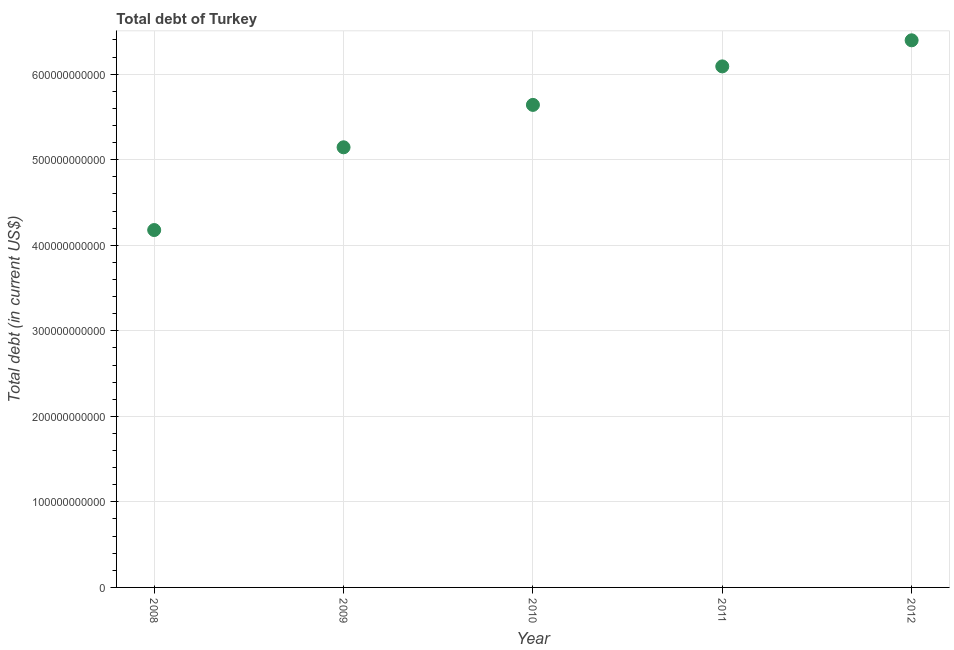What is the total debt in 2010?
Ensure brevity in your answer.  5.64e+11. Across all years, what is the maximum total debt?
Your answer should be very brief. 6.40e+11. Across all years, what is the minimum total debt?
Your answer should be compact. 4.18e+11. In which year was the total debt minimum?
Keep it short and to the point. 2008. What is the sum of the total debt?
Your answer should be very brief. 2.75e+12. What is the difference between the total debt in 2010 and 2012?
Keep it short and to the point. -7.55e+1. What is the average total debt per year?
Provide a succinct answer. 5.49e+11. What is the median total debt?
Your answer should be compact. 5.64e+11. In how many years, is the total debt greater than 380000000000 US$?
Provide a succinct answer. 5. What is the ratio of the total debt in 2008 to that in 2010?
Ensure brevity in your answer.  0.74. Is the total debt in 2008 less than that in 2009?
Provide a short and direct response. Yes. What is the difference between the highest and the second highest total debt?
Offer a terse response. 3.05e+1. What is the difference between the highest and the lowest total debt?
Ensure brevity in your answer.  2.22e+11. In how many years, is the total debt greater than the average total debt taken over all years?
Your answer should be very brief. 3. Does the total debt monotonically increase over the years?
Keep it short and to the point. Yes. How many years are there in the graph?
Your response must be concise. 5. What is the difference between two consecutive major ticks on the Y-axis?
Offer a terse response. 1.00e+11. Are the values on the major ticks of Y-axis written in scientific E-notation?
Your answer should be compact. No. What is the title of the graph?
Give a very brief answer. Total debt of Turkey. What is the label or title of the X-axis?
Keep it short and to the point. Year. What is the label or title of the Y-axis?
Your answer should be compact. Total debt (in current US$). What is the Total debt (in current US$) in 2008?
Provide a short and direct response. 4.18e+11. What is the Total debt (in current US$) in 2009?
Give a very brief answer. 5.15e+11. What is the Total debt (in current US$) in 2010?
Your answer should be very brief. 5.64e+11. What is the Total debt (in current US$) in 2011?
Ensure brevity in your answer.  6.09e+11. What is the Total debt (in current US$) in 2012?
Ensure brevity in your answer.  6.40e+11. What is the difference between the Total debt (in current US$) in 2008 and 2009?
Your response must be concise. -9.67e+1. What is the difference between the Total debt (in current US$) in 2008 and 2010?
Ensure brevity in your answer.  -1.46e+11. What is the difference between the Total debt (in current US$) in 2008 and 2011?
Your answer should be compact. -1.91e+11. What is the difference between the Total debt (in current US$) in 2008 and 2012?
Provide a short and direct response. -2.22e+11. What is the difference between the Total debt (in current US$) in 2009 and 2010?
Offer a terse response. -4.96e+1. What is the difference between the Total debt (in current US$) in 2009 and 2011?
Your response must be concise. -9.46e+1. What is the difference between the Total debt (in current US$) in 2009 and 2012?
Your answer should be compact. -1.25e+11. What is the difference between the Total debt (in current US$) in 2010 and 2011?
Your answer should be compact. -4.50e+1. What is the difference between the Total debt (in current US$) in 2010 and 2012?
Offer a very short reply. -7.55e+1. What is the difference between the Total debt (in current US$) in 2011 and 2012?
Offer a terse response. -3.05e+1. What is the ratio of the Total debt (in current US$) in 2008 to that in 2009?
Provide a short and direct response. 0.81. What is the ratio of the Total debt (in current US$) in 2008 to that in 2010?
Make the answer very short. 0.74. What is the ratio of the Total debt (in current US$) in 2008 to that in 2011?
Offer a very short reply. 0.69. What is the ratio of the Total debt (in current US$) in 2008 to that in 2012?
Offer a very short reply. 0.65. What is the ratio of the Total debt (in current US$) in 2009 to that in 2010?
Ensure brevity in your answer.  0.91. What is the ratio of the Total debt (in current US$) in 2009 to that in 2011?
Ensure brevity in your answer.  0.84. What is the ratio of the Total debt (in current US$) in 2009 to that in 2012?
Your response must be concise. 0.8. What is the ratio of the Total debt (in current US$) in 2010 to that in 2011?
Provide a succinct answer. 0.93. What is the ratio of the Total debt (in current US$) in 2010 to that in 2012?
Your response must be concise. 0.88. 